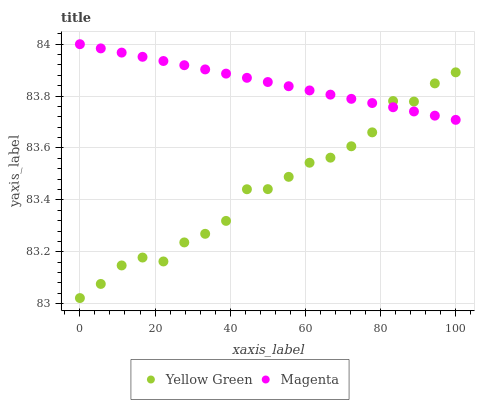Does Yellow Green have the minimum area under the curve?
Answer yes or no. Yes. Does Magenta have the maximum area under the curve?
Answer yes or no. Yes. Does Yellow Green have the maximum area under the curve?
Answer yes or no. No. Is Magenta the smoothest?
Answer yes or no. Yes. Is Yellow Green the roughest?
Answer yes or no. Yes. Is Yellow Green the smoothest?
Answer yes or no. No. Does Yellow Green have the lowest value?
Answer yes or no. Yes. Does Magenta have the highest value?
Answer yes or no. Yes. Does Yellow Green have the highest value?
Answer yes or no. No. Does Magenta intersect Yellow Green?
Answer yes or no. Yes. Is Magenta less than Yellow Green?
Answer yes or no. No. Is Magenta greater than Yellow Green?
Answer yes or no. No. 